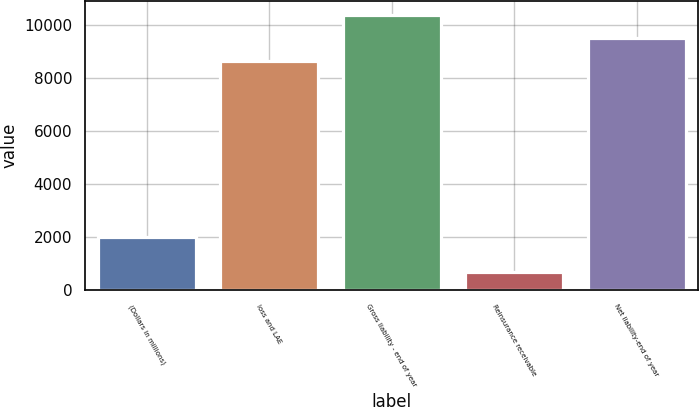<chart> <loc_0><loc_0><loc_500><loc_500><bar_chart><fcel>(Dollars in millions)<fcel>loss and LAE<fcel>Gross liability - end of year<fcel>Reinsurance receivable<fcel>Net liability-end of year<nl><fcel>2010<fcel>8650.7<fcel>10380.8<fcel>689.4<fcel>9515.77<nl></chart> 